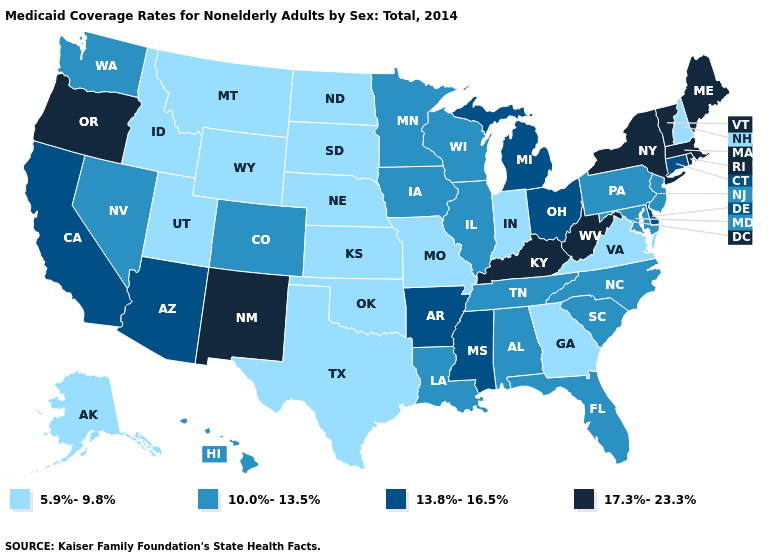Name the states that have a value in the range 17.3%-23.3%?
Quick response, please. Kentucky, Maine, Massachusetts, New Mexico, New York, Oregon, Rhode Island, Vermont, West Virginia. What is the lowest value in the Northeast?
Concise answer only. 5.9%-9.8%. Name the states that have a value in the range 17.3%-23.3%?
Keep it brief. Kentucky, Maine, Massachusetts, New Mexico, New York, Oregon, Rhode Island, Vermont, West Virginia. Which states have the lowest value in the USA?
Write a very short answer. Alaska, Georgia, Idaho, Indiana, Kansas, Missouri, Montana, Nebraska, New Hampshire, North Dakota, Oklahoma, South Dakota, Texas, Utah, Virginia, Wyoming. What is the value of Virginia?
Answer briefly. 5.9%-9.8%. Name the states that have a value in the range 13.8%-16.5%?
Quick response, please. Arizona, Arkansas, California, Connecticut, Delaware, Michigan, Mississippi, Ohio. What is the lowest value in the South?
Concise answer only. 5.9%-9.8%. Name the states that have a value in the range 13.8%-16.5%?
Be succinct. Arizona, Arkansas, California, Connecticut, Delaware, Michigan, Mississippi, Ohio. Which states have the lowest value in the USA?
Write a very short answer. Alaska, Georgia, Idaho, Indiana, Kansas, Missouri, Montana, Nebraska, New Hampshire, North Dakota, Oklahoma, South Dakota, Texas, Utah, Virginia, Wyoming. How many symbols are there in the legend?
Answer briefly. 4. Among the states that border Kentucky , which have the lowest value?
Give a very brief answer. Indiana, Missouri, Virginia. Name the states that have a value in the range 13.8%-16.5%?
Answer briefly. Arizona, Arkansas, California, Connecticut, Delaware, Michigan, Mississippi, Ohio. What is the lowest value in the USA?
Write a very short answer. 5.9%-9.8%. Does Maine have the highest value in the USA?
Write a very short answer. Yes. Does New Jersey have a lower value than Hawaii?
Keep it brief. No. 